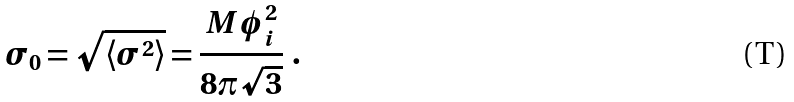<formula> <loc_0><loc_0><loc_500><loc_500>\sigma _ { 0 } = \sqrt { \langle \sigma ^ { 2 } \rangle } = { \frac { M \phi _ { i } ^ { 2 } } { 8 \pi \sqrt { 3 } } } \ .</formula> 